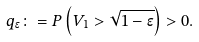<formula> <loc_0><loc_0><loc_500><loc_500>q _ { \epsilon } \colon = P \left ( V _ { 1 } > \sqrt { 1 - \epsilon } \right ) > 0 .</formula> 